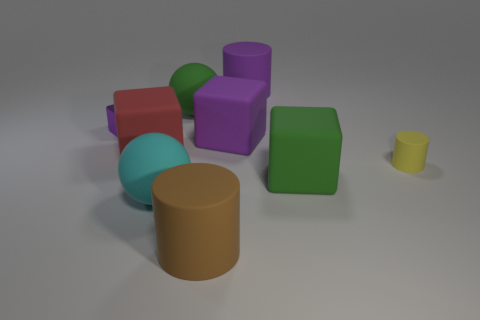Add 1 small yellow rubber cylinders. How many objects exist? 10 Subtract all big cylinders. How many cylinders are left? 1 Subtract all balls. How many objects are left? 7 Subtract all green cylinders. How many purple cubes are left? 2 Subtract all cyan balls. Subtract all gray cubes. How many balls are left? 1 Subtract all large green metal cylinders. Subtract all large green cubes. How many objects are left? 8 Add 8 large cyan things. How many large cyan things are left? 9 Add 6 big matte spheres. How many big matte spheres exist? 8 Subtract all red cubes. How many cubes are left? 3 Subtract 0 red cylinders. How many objects are left? 9 